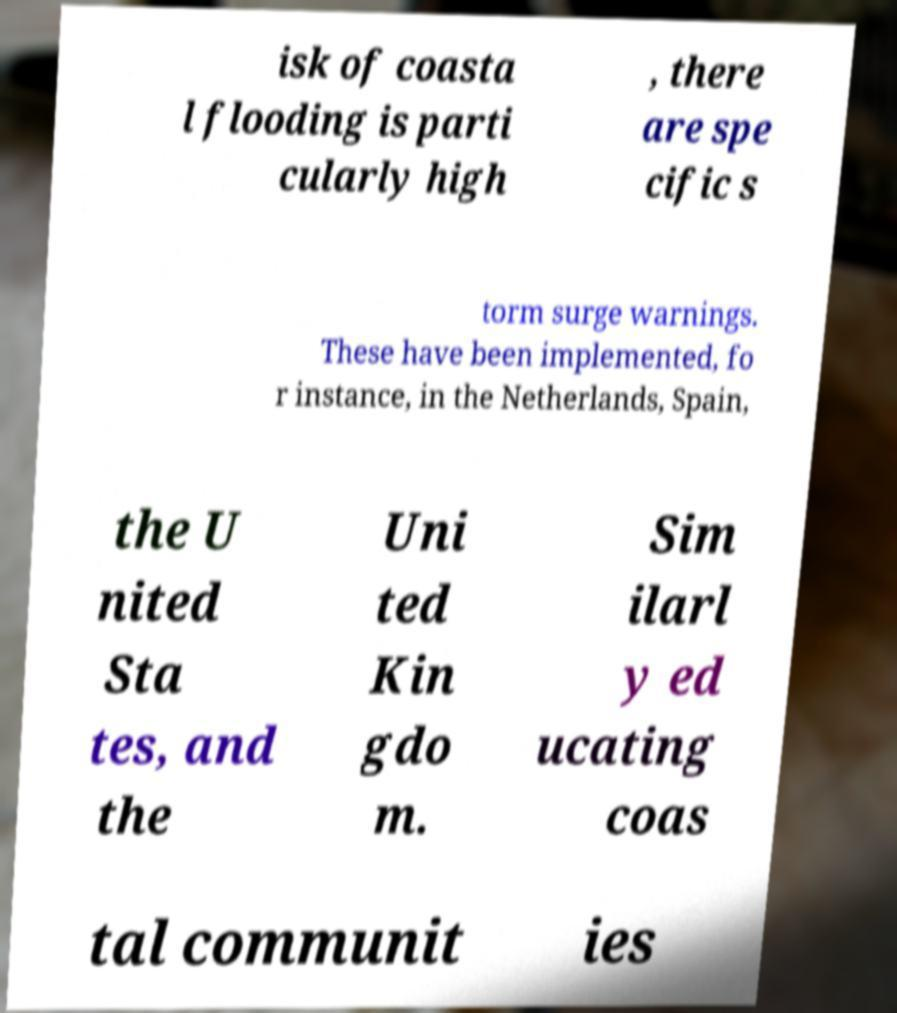Could you extract and type out the text from this image? isk of coasta l flooding is parti cularly high , there are spe cific s torm surge warnings. These have been implemented, fo r instance, in the Netherlands, Spain, the U nited Sta tes, and the Uni ted Kin gdo m. Sim ilarl y ed ucating coas tal communit ies 